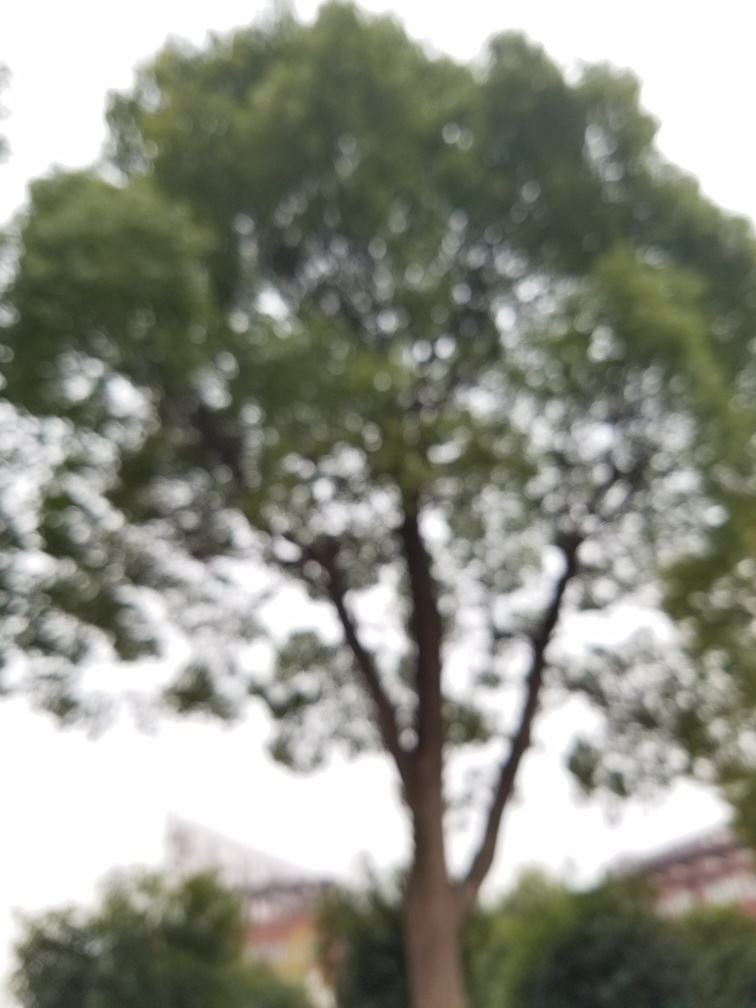Could the blurriness of this photo be intentional, and if so, why might a photographer choose to do this? Yes, the blurriness might be an intentional artistic choice. A photographer could use this technique to evoke certain emotions, create an atmosphere of mystery, or draw attention to elements that don't rely on clarity to be appreciated. It can also be used to emphasize the concept of memory or the passage of time, often seen in dream-like or ethereal compositions. 